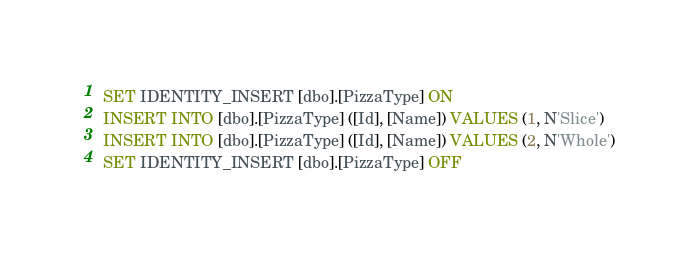Convert code to text. <code><loc_0><loc_0><loc_500><loc_500><_SQL_>SET IDENTITY_INSERT [dbo].[PizzaType] ON
INSERT INTO [dbo].[PizzaType] ([Id], [Name]) VALUES (1, N'Slice')
INSERT INTO [dbo].[PizzaType] ([Id], [Name]) VALUES (2, N'Whole')
SET IDENTITY_INSERT [dbo].[PizzaType] OFF
</code> 